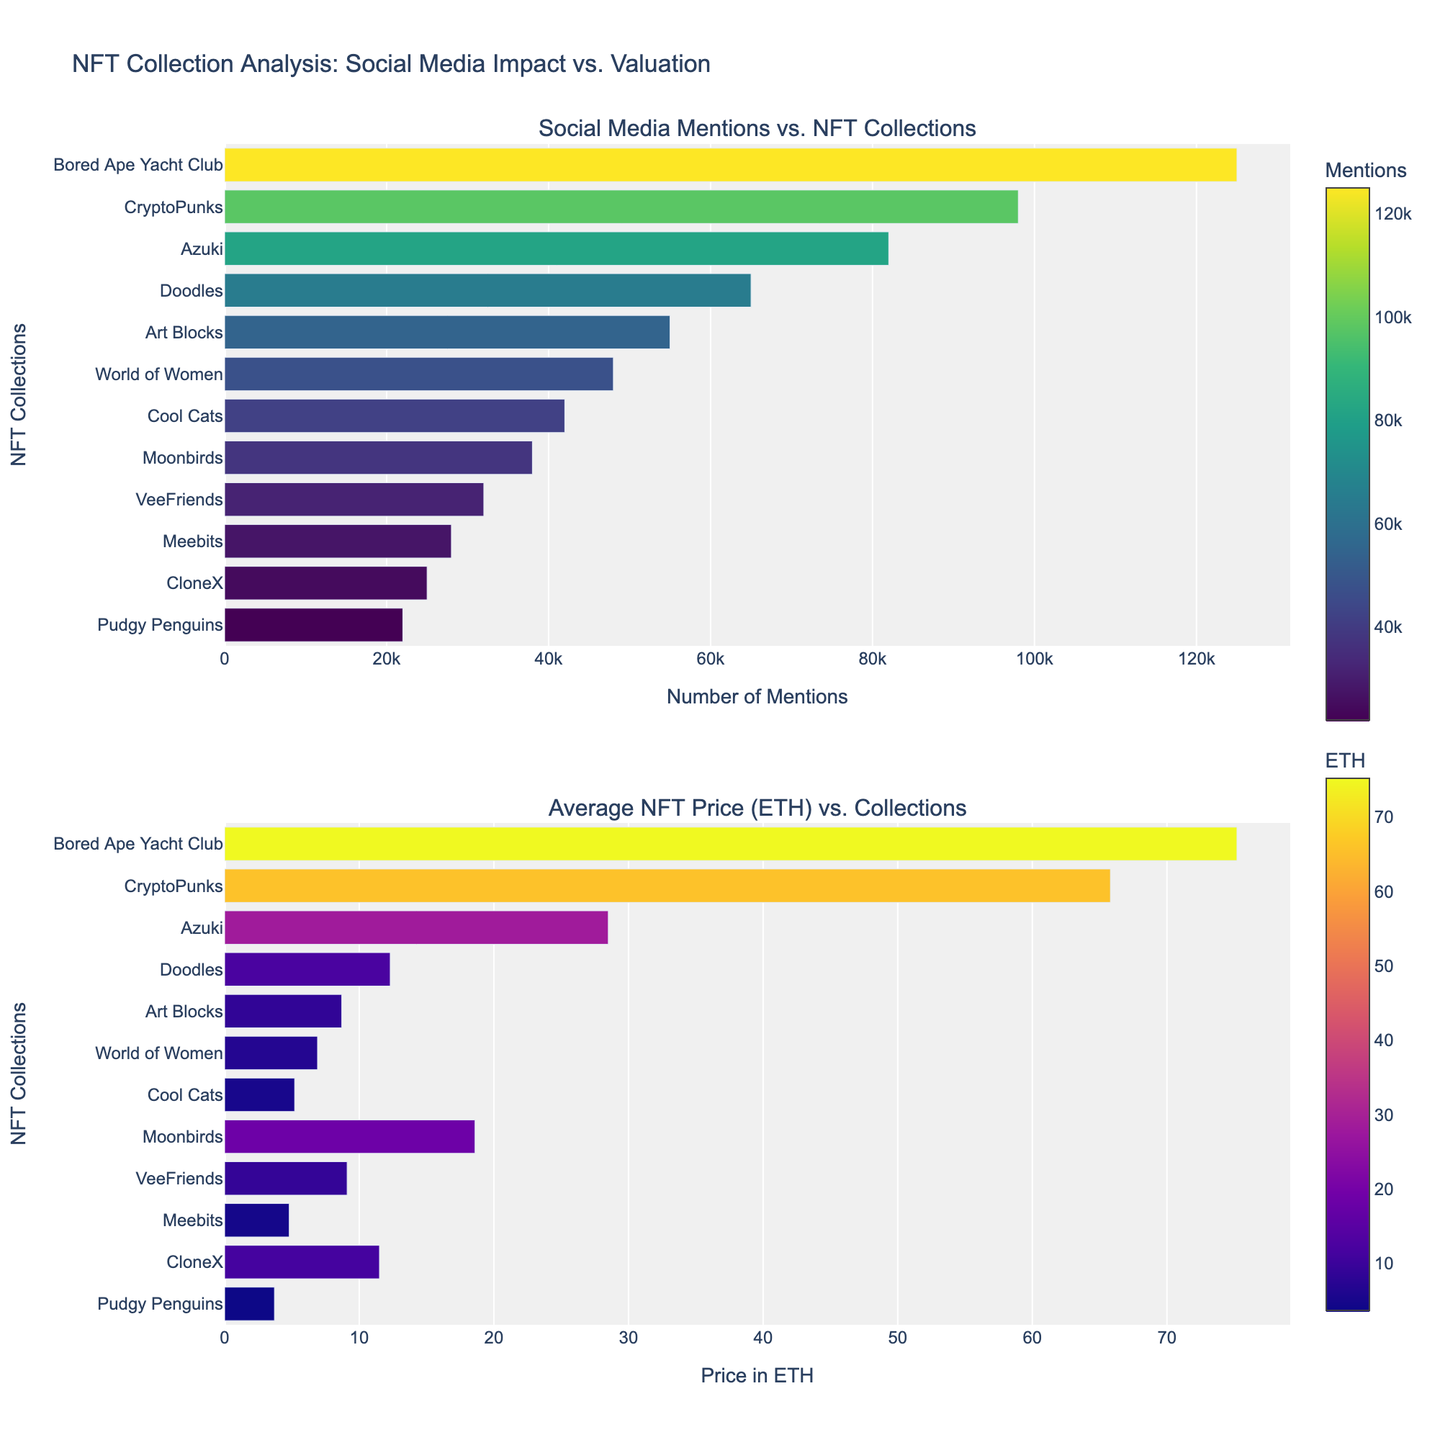Which NFT collection has the highest number of social media mentions? The collection with the highest bar in the top subplot of the figure represents the highest number of social media mentions.
Answer: Bored Ape Yacht Club What is the average NFT price for CryptoPunks in ETH? From the bottom subplot, locate the bar corresponding to CryptoPunks on the y-axis and read its value on the x-axis.
Answer: 65.8 Which NFT collection shows a higher average price in ETH, Azuki or Moonbirds? Compare the bar heights corresponding to Azuki and Moonbirds in the bottom subplot.
Answer: Azuki How many NFT collections have a social media mention count greater than 50,000? Count the number of bars in the top subplot that extend beyond the 50,000 mark on the x-axis.
Answer: 5 What is the overall trend between social media mentions and average NFT prices? Observe the general pattern or correlation in the heights of bars in both subplots. Typically, more social media mentions correlate with higher average prices.
Answer: Positive correlation Which collection has the closest social media mentions to 40,000? Identify the bar in the top subplot that is nearest to but does not exceed 40,000.
Answer: Cool Cats What is the total social media mention count for the collections with mentions below 30,000? Add the mention counts of all collections with bars below 30,000 in the top subplot (VeeFriends, Meebits, CloneX, Pudgy Penguins).
Answer: 107000 Are there any collections with a high number of social media mentions but a relatively low NFT price? Identify collections with tall bars in the top subplot and shorter bars in the bottom subplot. Doodles fits this description.
Answer: Doodles Which NFT collection has the lowest average price in ETH? Locate the shortest bar in the bottom subplot in terms of height.
Answer: Pudgy Penguins 